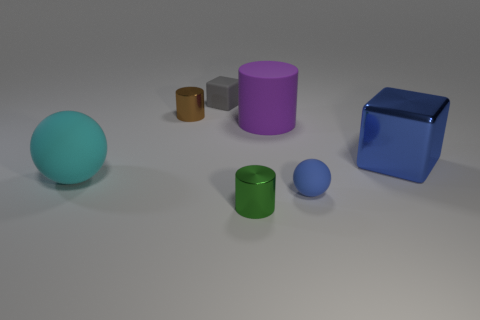Does the gray matte object have the same shape as the tiny metallic object that is behind the large purple thing?
Offer a very short reply. No. How many blocks are right of the tiny gray rubber block and left of the big block?
Give a very brief answer. 0. What is the material of the gray thing that is the same shape as the blue metallic object?
Give a very brief answer. Rubber. What size is the cylinder that is in front of the big metal cube behind the tiny blue object?
Offer a terse response. Small. Are there any tiny objects?
Offer a very short reply. Yes. What material is the tiny object that is both in front of the small gray matte thing and behind the cyan matte object?
Your response must be concise. Metal. Are there more objects on the left side of the rubber block than small blue rubber balls that are left of the tiny blue matte thing?
Your answer should be compact. Yes. Are there any brown shiny cylinders of the same size as the cyan sphere?
Give a very brief answer. No. There is a cylinder right of the small metal cylinder in front of the cube that is in front of the purple thing; what size is it?
Provide a short and direct response. Large. What color is the big cylinder?
Provide a short and direct response. Purple. 